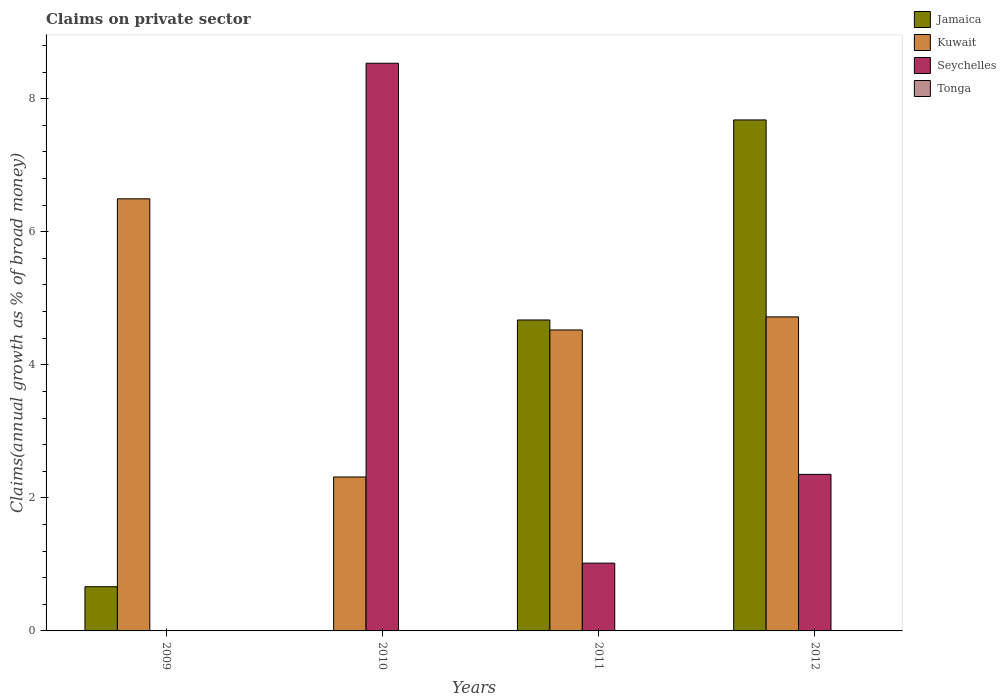How many groups of bars are there?
Keep it short and to the point. 4. Are the number of bars per tick equal to the number of legend labels?
Your answer should be compact. No. How many bars are there on the 2nd tick from the left?
Give a very brief answer. 2. Across all years, what is the maximum percentage of broad money claimed on private sector in Jamaica?
Keep it short and to the point. 7.68. Across all years, what is the minimum percentage of broad money claimed on private sector in Seychelles?
Offer a terse response. 0. In which year was the percentage of broad money claimed on private sector in Kuwait maximum?
Provide a succinct answer. 2009. What is the total percentage of broad money claimed on private sector in Jamaica in the graph?
Give a very brief answer. 13.02. What is the difference between the percentage of broad money claimed on private sector in Kuwait in 2009 and that in 2010?
Ensure brevity in your answer.  4.18. What is the average percentage of broad money claimed on private sector in Seychelles per year?
Keep it short and to the point. 2.98. In the year 2009, what is the difference between the percentage of broad money claimed on private sector in Jamaica and percentage of broad money claimed on private sector in Kuwait?
Keep it short and to the point. -5.83. What is the ratio of the percentage of broad money claimed on private sector in Kuwait in 2011 to that in 2012?
Provide a short and direct response. 0.96. Is the percentage of broad money claimed on private sector in Seychelles in 2010 less than that in 2011?
Give a very brief answer. No. What is the difference between the highest and the second highest percentage of broad money claimed on private sector in Jamaica?
Your answer should be very brief. 3.01. What is the difference between the highest and the lowest percentage of broad money claimed on private sector in Jamaica?
Offer a very short reply. 7.68. Is it the case that in every year, the sum of the percentage of broad money claimed on private sector in Jamaica and percentage of broad money claimed on private sector in Tonga is greater than the percentage of broad money claimed on private sector in Seychelles?
Offer a terse response. No. Are all the bars in the graph horizontal?
Provide a short and direct response. No. What is the difference between two consecutive major ticks on the Y-axis?
Your answer should be very brief. 2. Are the values on the major ticks of Y-axis written in scientific E-notation?
Your answer should be compact. No. Does the graph contain any zero values?
Offer a terse response. Yes. Where does the legend appear in the graph?
Provide a short and direct response. Top right. How are the legend labels stacked?
Ensure brevity in your answer.  Vertical. What is the title of the graph?
Offer a terse response. Claims on private sector. Does "Chile" appear as one of the legend labels in the graph?
Ensure brevity in your answer.  No. What is the label or title of the Y-axis?
Offer a terse response. Claims(annual growth as % of broad money). What is the Claims(annual growth as % of broad money) of Jamaica in 2009?
Offer a very short reply. 0.66. What is the Claims(annual growth as % of broad money) in Kuwait in 2009?
Offer a terse response. 6.5. What is the Claims(annual growth as % of broad money) of Seychelles in 2009?
Offer a terse response. 0. What is the Claims(annual growth as % of broad money) of Jamaica in 2010?
Give a very brief answer. 0. What is the Claims(annual growth as % of broad money) of Kuwait in 2010?
Your answer should be very brief. 2.31. What is the Claims(annual growth as % of broad money) in Seychelles in 2010?
Offer a terse response. 8.53. What is the Claims(annual growth as % of broad money) of Jamaica in 2011?
Give a very brief answer. 4.67. What is the Claims(annual growth as % of broad money) in Kuwait in 2011?
Provide a short and direct response. 4.52. What is the Claims(annual growth as % of broad money) in Seychelles in 2011?
Offer a very short reply. 1.02. What is the Claims(annual growth as % of broad money) in Tonga in 2011?
Your answer should be compact. 0. What is the Claims(annual growth as % of broad money) in Jamaica in 2012?
Your answer should be very brief. 7.68. What is the Claims(annual growth as % of broad money) of Kuwait in 2012?
Your answer should be compact. 4.72. What is the Claims(annual growth as % of broad money) of Seychelles in 2012?
Give a very brief answer. 2.35. Across all years, what is the maximum Claims(annual growth as % of broad money) in Jamaica?
Your response must be concise. 7.68. Across all years, what is the maximum Claims(annual growth as % of broad money) of Kuwait?
Ensure brevity in your answer.  6.5. Across all years, what is the maximum Claims(annual growth as % of broad money) of Seychelles?
Make the answer very short. 8.53. Across all years, what is the minimum Claims(annual growth as % of broad money) in Jamaica?
Ensure brevity in your answer.  0. Across all years, what is the minimum Claims(annual growth as % of broad money) in Kuwait?
Keep it short and to the point. 2.31. What is the total Claims(annual growth as % of broad money) in Jamaica in the graph?
Provide a succinct answer. 13.02. What is the total Claims(annual growth as % of broad money) of Kuwait in the graph?
Your answer should be compact. 18.05. What is the total Claims(annual growth as % of broad money) in Seychelles in the graph?
Provide a succinct answer. 11.9. What is the difference between the Claims(annual growth as % of broad money) of Kuwait in 2009 and that in 2010?
Make the answer very short. 4.18. What is the difference between the Claims(annual growth as % of broad money) in Jamaica in 2009 and that in 2011?
Provide a succinct answer. -4.01. What is the difference between the Claims(annual growth as % of broad money) in Kuwait in 2009 and that in 2011?
Your answer should be compact. 1.97. What is the difference between the Claims(annual growth as % of broad money) in Jamaica in 2009 and that in 2012?
Offer a very short reply. -7.02. What is the difference between the Claims(annual growth as % of broad money) in Kuwait in 2009 and that in 2012?
Keep it short and to the point. 1.77. What is the difference between the Claims(annual growth as % of broad money) of Kuwait in 2010 and that in 2011?
Offer a very short reply. -2.21. What is the difference between the Claims(annual growth as % of broad money) in Seychelles in 2010 and that in 2011?
Your answer should be very brief. 7.51. What is the difference between the Claims(annual growth as % of broad money) in Kuwait in 2010 and that in 2012?
Provide a succinct answer. -2.41. What is the difference between the Claims(annual growth as % of broad money) of Seychelles in 2010 and that in 2012?
Your response must be concise. 6.18. What is the difference between the Claims(annual growth as % of broad money) in Jamaica in 2011 and that in 2012?
Ensure brevity in your answer.  -3.01. What is the difference between the Claims(annual growth as % of broad money) of Kuwait in 2011 and that in 2012?
Your answer should be compact. -0.2. What is the difference between the Claims(annual growth as % of broad money) in Seychelles in 2011 and that in 2012?
Ensure brevity in your answer.  -1.33. What is the difference between the Claims(annual growth as % of broad money) of Jamaica in 2009 and the Claims(annual growth as % of broad money) of Kuwait in 2010?
Ensure brevity in your answer.  -1.65. What is the difference between the Claims(annual growth as % of broad money) of Jamaica in 2009 and the Claims(annual growth as % of broad money) of Seychelles in 2010?
Offer a very short reply. -7.87. What is the difference between the Claims(annual growth as % of broad money) in Kuwait in 2009 and the Claims(annual growth as % of broad money) in Seychelles in 2010?
Make the answer very short. -2.04. What is the difference between the Claims(annual growth as % of broad money) in Jamaica in 2009 and the Claims(annual growth as % of broad money) in Kuwait in 2011?
Give a very brief answer. -3.86. What is the difference between the Claims(annual growth as % of broad money) in Jamaica in 2009 and the Claims(annual growth as % of broad money) in Seychelles in 2011?
Your response must be concise. -0.35. What is the difference between the Claims(annual growth as % of broad money) of Kuwait in 2009 and the Claims(annual growth as % of broad money) of Seychelles in 2011?
Keep it short and to the point. 5.48. What is the difference between the Claims(annual growth as % of broad money) in Jamaica in 2009 and the Claims(annual growth as % of broad money) in Kuwait in 2012?
Keep it short and to the point. -4.06. What is the difference between the Claims(annual growth as % of broad money) in Jamaica in 2009 and the Claims(annual growth as % of broad money) in Seychelles in 2012?
Your response must be concise. -1.69. What is the difference between the Claims(annual growth as % of broad money) in Kuwait in 2009 and the Claims(annual growth as % of broad money) in Seychelles in 2012?
Keep it short and to the point. 4.14. What is the difference between the Claims(annual growth as % of broad money) in Kuwait in 2010 and the Claims(annual growth as % of broad money) in Seychelles in 2011?
Give a very brief answer. 1.3. What is the difference between the Claims(annual growth as % of broad money) in Kuwait in 2010 and the Claims(annual growth as % of broad money) in Seychelles in 2012?
Give a very brief answer. -0.04. What is the difference between the Claims(annual growth as % of broad money) of Jamaica in 2011 and the Claims(annual growth as % of broad money) of Kuwait in 2012?
Provide a succinct answer. -0.05. What is the difference between the Claims(annual growth as % of broad money) in Jamaica in 2011 and the Claims(annual growth as % of broad money) in Seychelles in 2012?
Ensure brevity in your answer.  2.32. What is the difference between the Claims(annual growth as % of broad money) of Kuwait in 2011 and the Claims(annual growth as % of broad money) of Seychelles in 2012?
Offer a terse response. 2.17. What is the average Claims(annual growth as % of broad money) of Jamaica per year?
Offer a very short reply. 3.25. What is the average Claims(annual growth as % of broad money) in Kuwait per year?
Your answer should be very brief. 4.51. What is the average Claims(annual growth as % of broad money) in Seychelles per year?
Offer a very short reply. 2.98. What is the average Claims(annual growth as % of broad money) in Tonga per year?
Give a very brief answer. 0. In the year 2009, what is the difference between the Claims(annual growth as % of broad money) in Jamaica and Claims(annual growth as % of broad money) in Kuwait?
Keep it short and to the point. -5.83. In the year 2010, what is the difference between the Claims(annual growth as % of broad money) in Kuwait and Claims(annual growth as % of broad money) in Seychelles?
Make the answer very short. -6.22. In the year 2011, what is the difference between the Claims(annual growth as % of broad money) of Jamaica and Claims(annual growth as % of broad money) of Seychelles?
Provide a short and direct response. 3.66. In the year 2011, what is the difference between the Claims(annual growth as % of broad money) in Kuwait and Claims(annual growth as % of broad money) in Seychelles?
Ensure brevity in your answer.  3.51. In the year 2012, what is the difference between the Claims(annual growth as % of broad money) in Jamaica and Claims(annual growth as % of broad money) in Kuwait?
Keep it short and to the point. 2.96. In the year 2012, what is the difference between the Claims(annual growth as % of broad money) in Jamaica and Claims(annual growth as % of broad money) in Seychelles?
Offer a terse response. 5.33. In the year 2012, what is the difference between the Claims(annual growth as % of broad money) of Kuwait and Claims(annual growth as % of broad money) of Seychelles?
Offer a terse response. 2.37. What is the ratio of the Claims(annual growth as % of broad money) of Kuwait in 2009 to that in 2010?
Provide a succinct answer. 2.81. What is the ratio of the Claims(annual growth as % of broad money) in Jamaica in 2009 to that in 2011?
Provide a short and direct response. 0.14. What is the ratio of the Claims(annual growth as % of broad money) in Kuwait in 2009 to that in 2011?
Provide a short and direct response. 1.44. What is the ratio of the Claims(annual growth as % of broad money) in Jamaica in 2009 to that in 2012?
Keep it short and to the point. 0.09. What is the ratio of the Claims(annual growth as % of broad money) in Kuwait in 2009 to that in 2012?
Your response must be concise. 1.38. What is the ratio of the Claims(annual growth as % of broad money) in Kuwait in 2010 to that in 2011?
Your response must be concise. 0.51. What is the ratio of the Claims(annual growth as % of broad money) in Seychelles in 2010 to that in 2011?
Keep it short and to the point. 8.38. What is the ratio of the Claims(annual growth as % of broad money) of Kuwait in 2010 to that in 2012?
Ensure brevity in your answer.  0.49. What is the ratio of the Claims(annual growth as % of broad money) of Seychelles in 2010 to that in 2012?
Provide a succinct answer. 3.63. What is the ratio of the Claims(annual growth as % of broad money) of Jamaica in 2011 to that in 2012?
Your response must be concise. 0.61. What is the ratio of the Claims(annual growth as % of broad money) of Kuwait in 2011 to that in 2012?
Offer a terse response. 0.96. What is the ratio of the Claims(annual growth as % of broad money) of Seychelles in 2011 to that in 2012?
Keep it short and to the point. 0.43. What is the difference between the highest and the second highest Claims(annual growth as % of broad money) of Jamaica?
Keep it short and to the point. 3.01. What is the difference between the highest and the second highest Claims(annual growth as % of broad money) of Kuwait?
Give a very brief answer. 1.77. What is the difference between the highest and the second highest Claims(annual growth as % of broad money) in Seychelles?
Offer a terse response. 6.18. What is the difference between the highest and the lowest Claims(annual growth as % of broad money) of Jamaica?
Provide a succinct answer. 7.68. What is the difference between the highest and the lowest Claims(annual growth as % of broad money) in Kuwait?
Offer a very short reply. 4.18. What is the difference between the highest and the lowest Claims(annual growth as % of broad money) of Seychelles?
Provide a succinct answer. 8.53. 